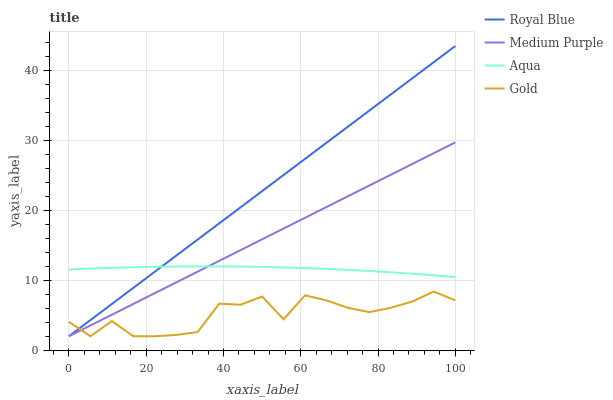Does Gold have the minimum area under the curve?
Answer yes or no. Yes. Does Royal Blue have the maximum area under the curve?
Answer yes or no. Yes. Does Aqua have the minimum area under the curve?
Answer yes or no. No. Does Aqua have the maximum area under the curve?
Answer yes or no. No. Is Medium Purple the smoothest?
Answer yes or no. Yes. Is Gold the roughest?
Answer yes or no. Yes. Is Royal Blue the smoothest?
Answer yes or no. No. Is Royal Blue the roughest?
Answer yes or no. No. Does Medium Purple have the lowest value?
Answer yes or no. Yes. Does Aqua have the lowest value?
Answer yes or no. No. Does Royal Blue have the highest value?
Answer yes or no. Yes. Does Aqua have the highest value?
Answer yes or no. No. Is Gold less than Aqua?
Answer yes or no. Yes. Is Aqua greater than Gold?
Answer yes or no. Yes. Does Aqua intersect Royal Blue?
Answer yes or no. Yes. Is Aqua less than Royal Blue?
Answer yes or no. No. Is Aqua greater than Royal Blue?
Answer yes or no. No. Does Gold intersect Aqua?
Answer yes or no. No. 